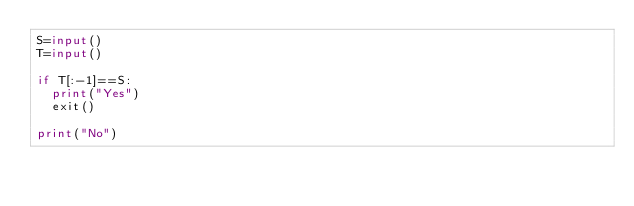Convert code to text. <code><loc_0><loc_0><loc_500><loc_500><_Python_>S=input()
T=input()

if T[:-1]==S:
	print("Yes")
	exit()

print("No")
</code> 